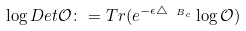<formula> <loc_0><loc_0><loc_500><loc_500>\log D e t \mathcal { O } \colon = T r ( e ^ { - \epsilon \triangle _ { \ B _ { c } } } \log \mathcal { O } )</formula> 